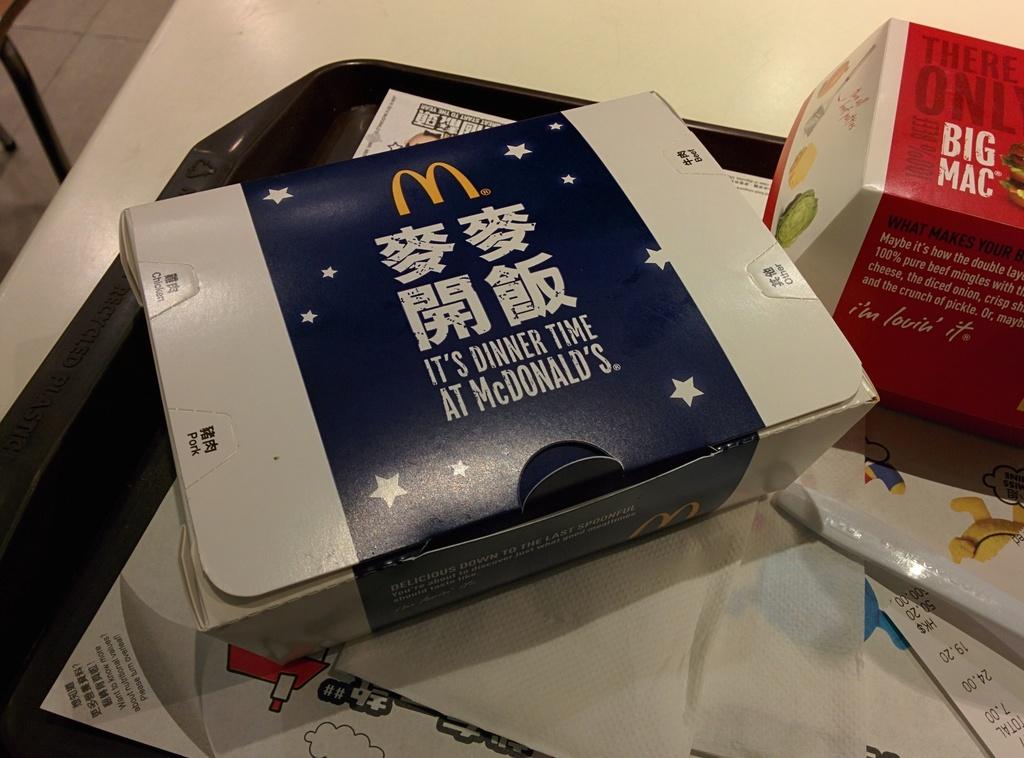Where is this food from?
Your answer should be very brief. Mcdonalds. What time is it?
Make the answer very short. Dinner time. 